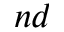Convert formula to latex. <formula><loc_0><loc_0><loc_500><loc_500>^ { n d }</formula> 